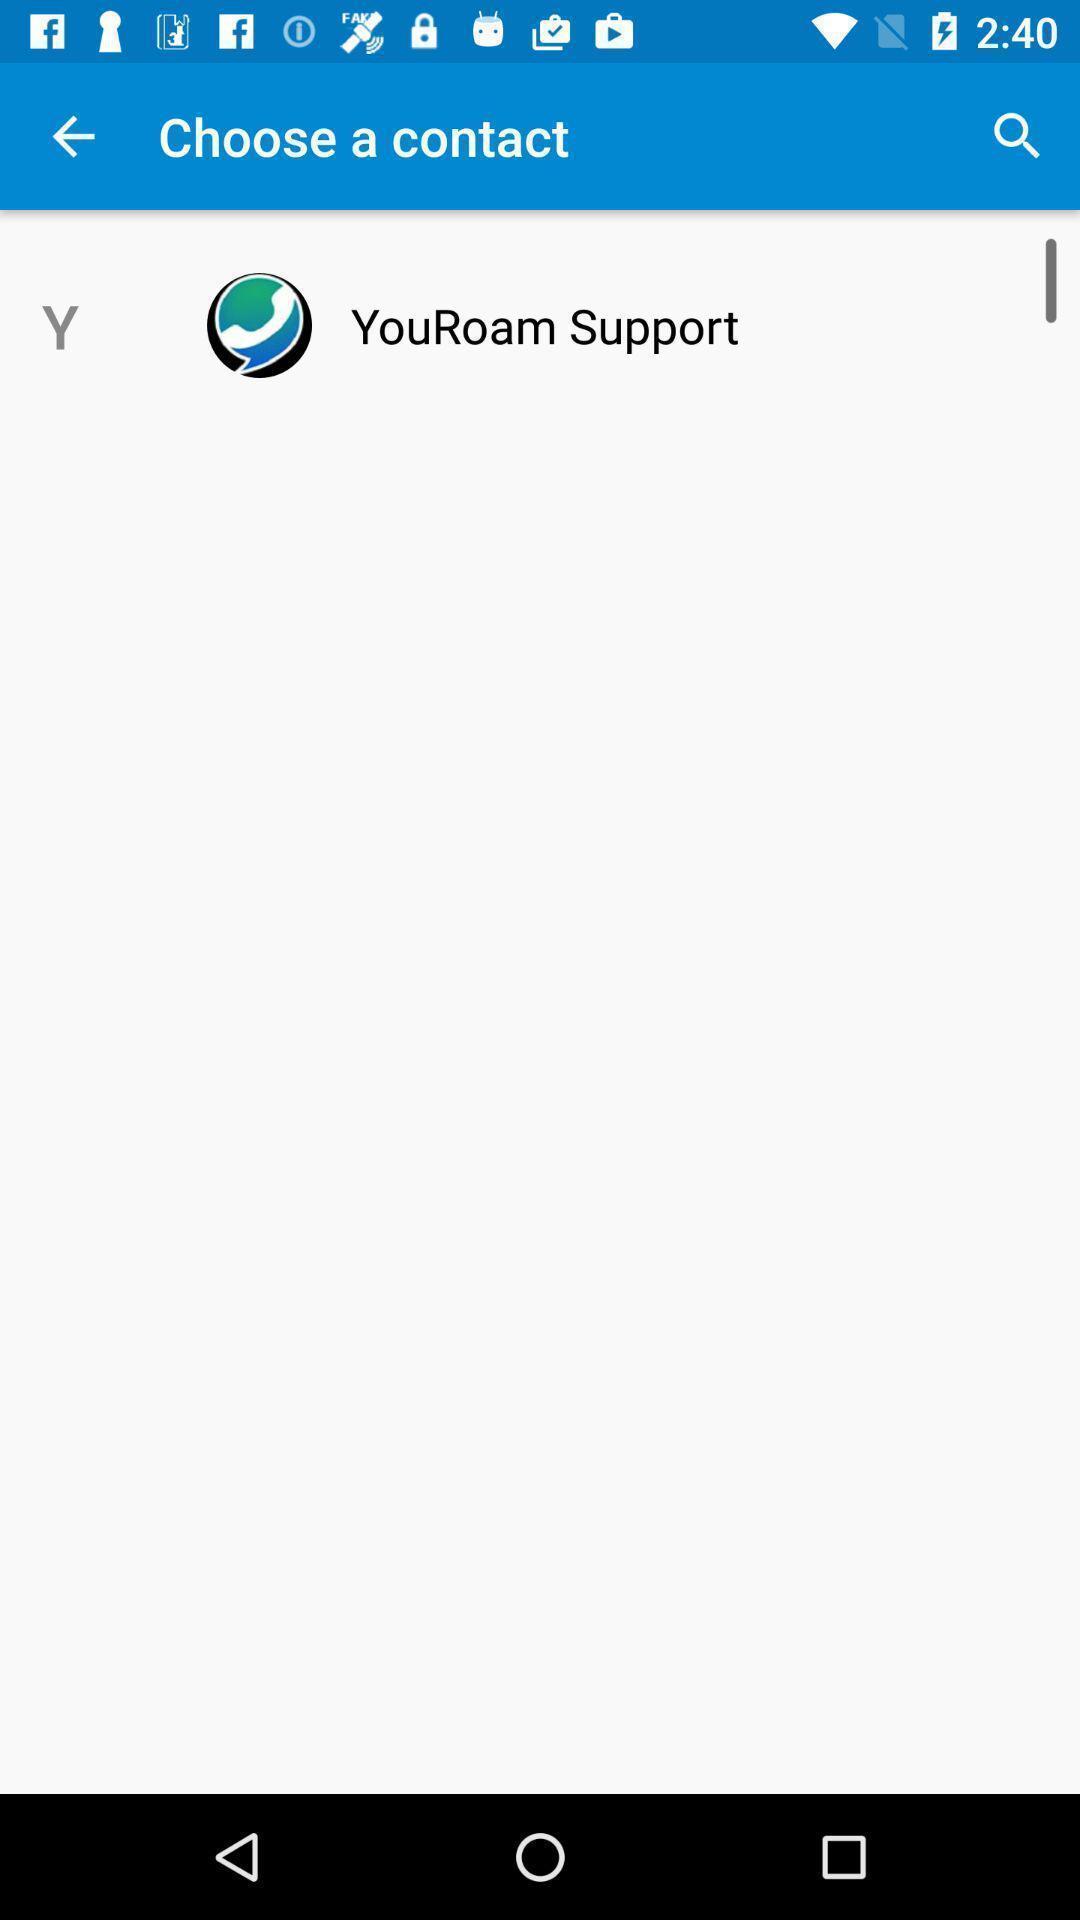Describe this image in words. Page displaying to choose a contact. 